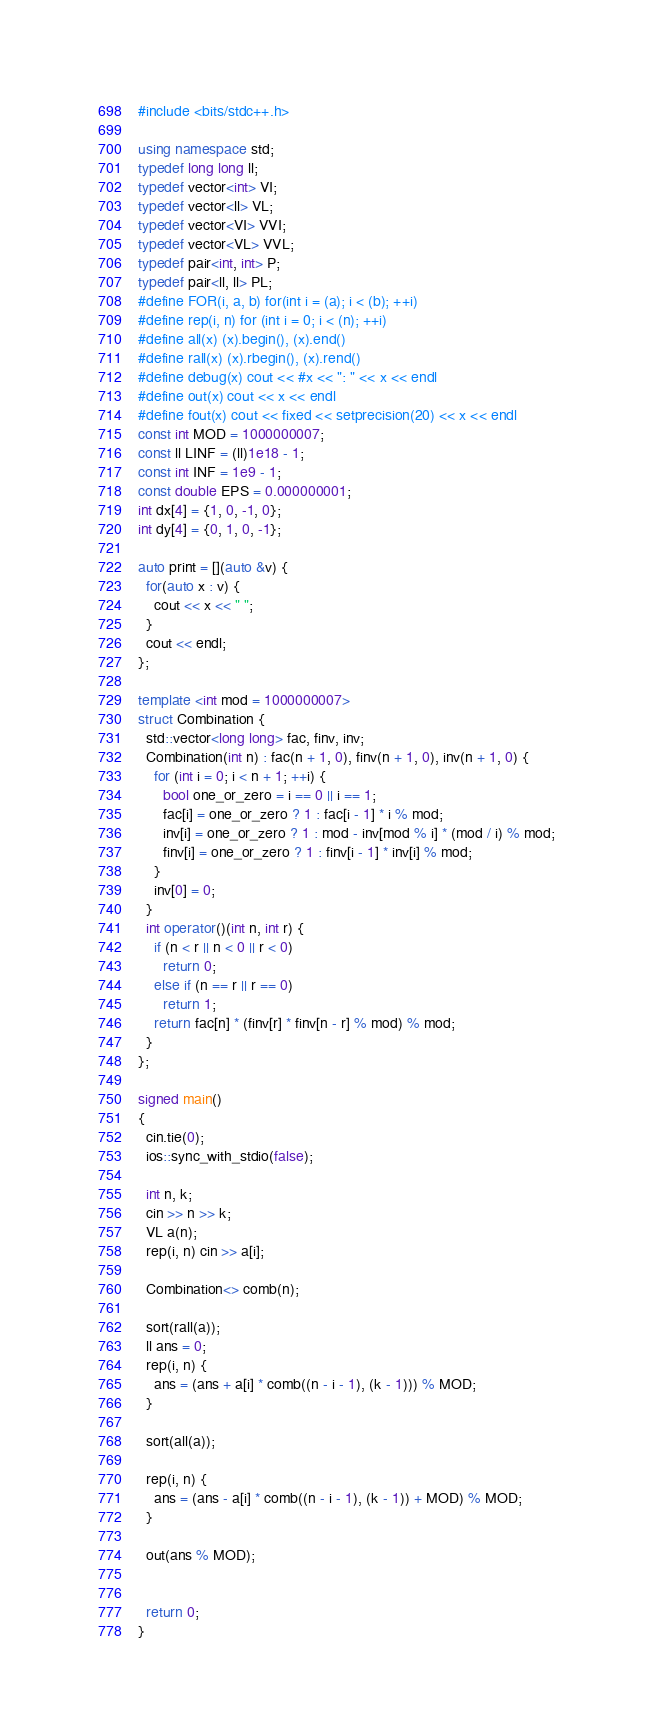<code> <loc_0><loc_0><loc_500><loc_500><_C++_>#include <bits/stdc++.h>

using namespace std;
typedef long long ll;
typedef vector<int> VI;
typedef vector<ll> VL;
typedef vector<VI> VVI;
typedef vector<VL> VVL;
typedef pair<int, int> P;
typedef pair<ll, ll> PL;
#define FOR(i, a, b) for(int i = (a); i < (b); ++i)
#define rep(i, n) for (int i = 0; i < (n); ++i)
#define all(x) (x).begin(), (x).end()
#define rall(x) (x).rbegin(), (x).rend()
#define debug(x) cout << #x << ": " << x << endl
#define out(x) cout << x << endl
#define fout(x) cout << fixed << setprecision(20) << x << endl
const int MOD = 1000000007;
const ll LINF = (ll)1e18 - 1;
const int INF = 1e9 - 1;
const double EPS = 0.000000001;
int dx[4] = {1, 0, -1, 0};
int dy[4] = {0, 1, 0, -1};

auto print = [](auto &v) {
  for(auto x : v) {
    cout << x << " ";
  }
  cout << endl;
};

template <int mod = 1000000007>
struct Combination {
  std::vector<long long> fac, finv, inv;
  Combination(int n) : fac(n + 1, 0), finv(n + 1, 0), inv(n + 1, 0) {
    for (int i = 0; i < n + 1; ++i) {
      bool one_or_zero = i == 0 || i == 1;
      fac[i] = one_or_zero ? 1 : fac[i - 1] * i % mod;
      inv[i] = one_or_zero ? 1 : mod - inv[mod % i] * (mod / i) % mod;
      finv[i] = one_or_zero ? 1 : finv[i - 1] * inv[i] % mod;
    }
    inv[0] = 0;
  }
  int operator()(int n, int r) {
    if (n < r || n < 0 || r < 0)
      return 0;
    else if (n == r || r == 0)
      return 1;
    return fac[n] * (finv[r] * finv[n - r] % mod) % mod;
  }
};

signed main()
{
  cin.tie(0);
  ios::sync_with_stdio(false);

  int n, k;
  cin >> n >> k;
  VL a(n);
  rep(i, n) cin >> a[i];

  Combination<> comb(n);

  sort(rall(a));
  ll ans = 0;
  rep(i, n) {
    ans = (ans + a[i] * comb((n - i - 1), (k - 1))) % MOD;
  }

  sort(all(a));

  rep(i, n) {
    ans = (ans - a[i] * comb((n - i - 1), (k - 1)) + MOD) % MOD;
  }

  out(ans % MOD);


  return 0;
}
</code> 